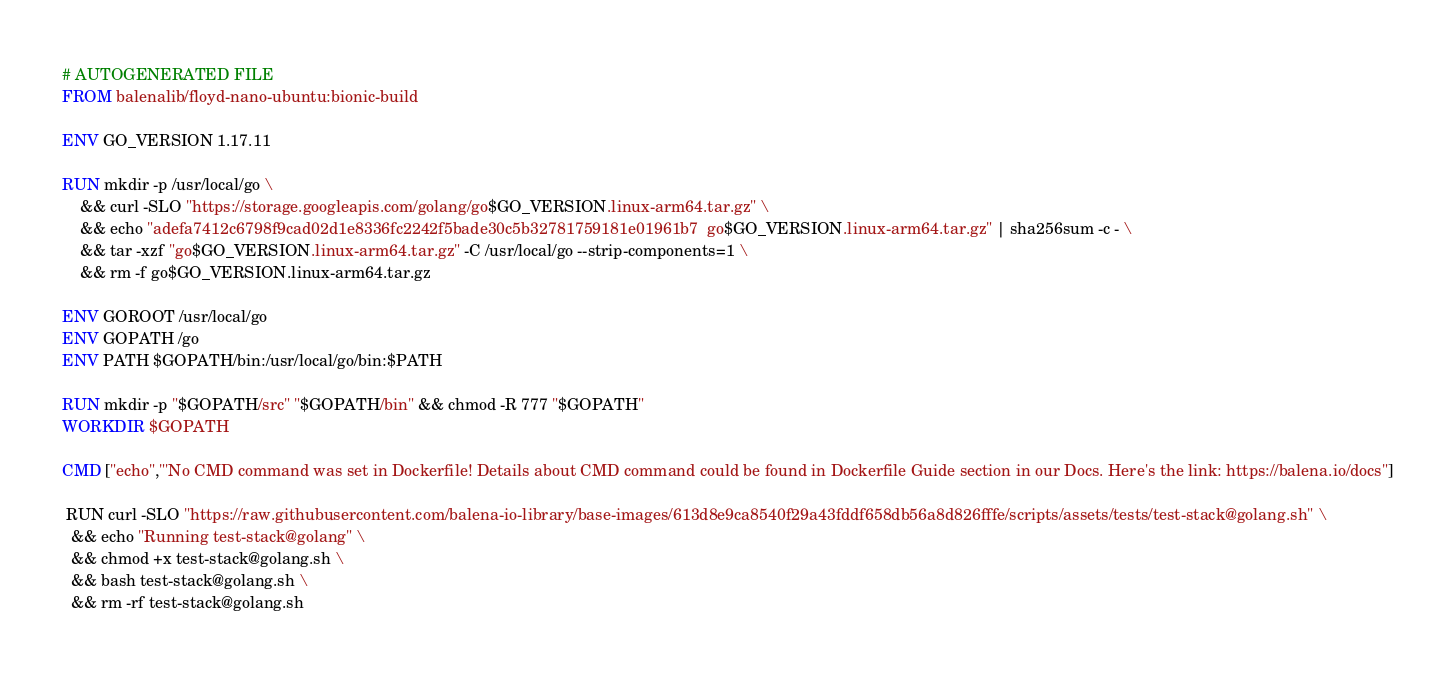<code> <loc_0><loc_0><loc_500><loc_500><_Dockerfile_># AUTOGENERATED FILE
FROM balenalib/floyd-nano-ubuntu:bionic-build

ENV GO_VERSION 1.17.11

RUN mkdir -p /usr/local/go \
	&& curl -SLO "https://storage.googleapis.com/golang/go$GO_VERSION.linux-arm64.tar.gz" \
	&& echo "adefa7412c6798f9cad02d1e8336fc2242f5bade30c5b32781759181e01961b7  go$GO_VERSION.linux-arm64.tar.gz" | sha256sum -c - \
	&& tar -xzf "go$GO_VERSION.linux-arm64.tar.gz" -C /usr/local/go --strip-components=1 \
	&& rm -f go$GO_VERSION.linux-arm64.tar.gz

ENV GOROOT /usr/local/go
ENV GOPATH /go
ENV PATH $GOPATH/bin:/usr/local/go/bin:$PATH

RUN mkdir -p "$GOPATH/src" "$GOPATH/bin" && chmod -R 777 "$GOPATH"
WORKDIR $GOPATH

CMD ["echo","'No CMD command was set in Dockerfile! Details about CMD command could be found in Dockerfile Guide section in our Docs. Here's the link: https://balena.io/docs"]

 RUN curl -SLO "https://raw.githubusercontent.com/balena-io-library/base-images/613d8e9ca8540f29a43fddf658db56a8d826fffe/scripts/assets/tests/test-stack@golang.sh" \
  && echo "Running test-stack@golang" \
  && chmod +x test-stack@golang.sh \
  && bash test-stack@golang.sh \
  && rm -rf test-stack@golang.sh 
</code> 